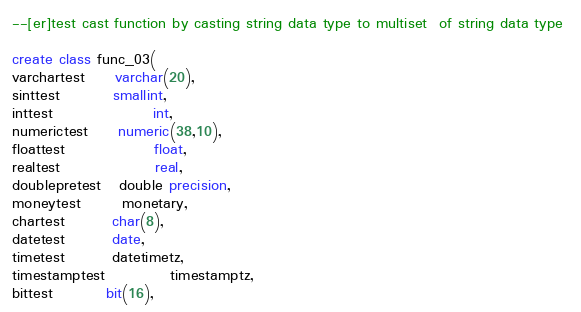Convert code to text. <code><loc_0><loc_0><loc_500><loc_500><_SQL_>--[er]test cast function by casting string data type to multiset  of string data type 

create class func_03(
varchartest     varchar(20),
sinttest         smallint,
inttest                 int,
numerictest     numeric(38,10),
floattest               float,
realtest                real,
doublepretest   double precision,
moneytest       monetary,
chartest        char(8),
datetest        date,
timetest        datetimetz,
timestamptest           timestamptz,
bittest         bit(16),</code> 